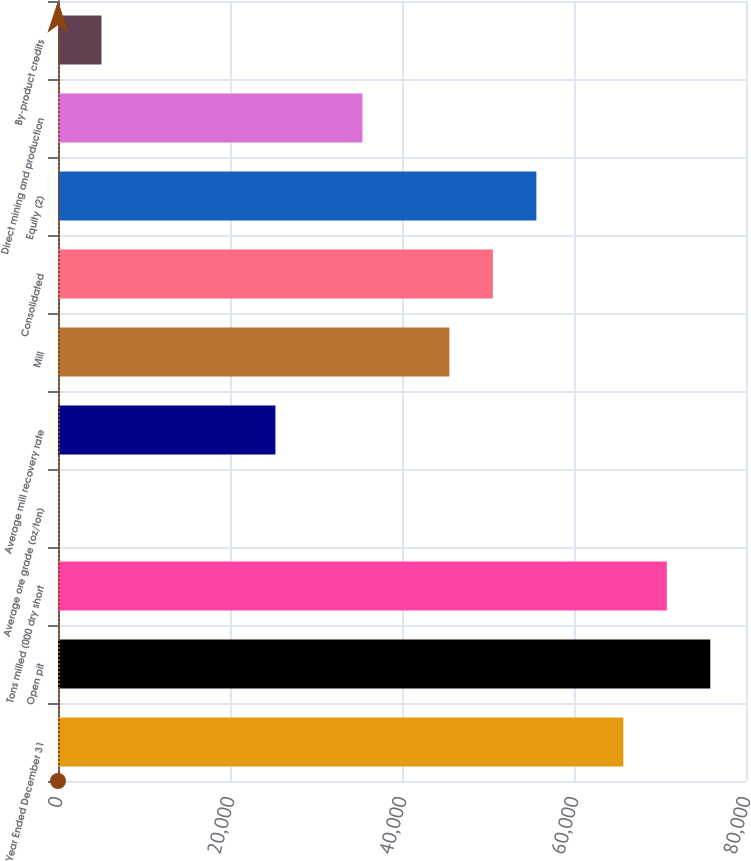Convert chart. <chart><loc_0><loc_0><loc_500><loc_500><bar_chart><fcel>Year Ended December 31<fcel>Open pit<fcel>Tons milled (000 dry short<fcel>Average ore grade (oz/ton)<fcel>Average mill recovery rate<fcel>Mill<fcel>Consolidated<fcel>Equity (2)<fcel>Direct mining and production<fcel>By-product credits<nl><fcel>65737<fcel>75850.4<fcel>70793.7<fcel>0.07<fcel>25283.5<fcel>45510.3<fcel>50567<fcel>55623.7<fcel>35396.9<fcel>5056.76<nl></chart> 